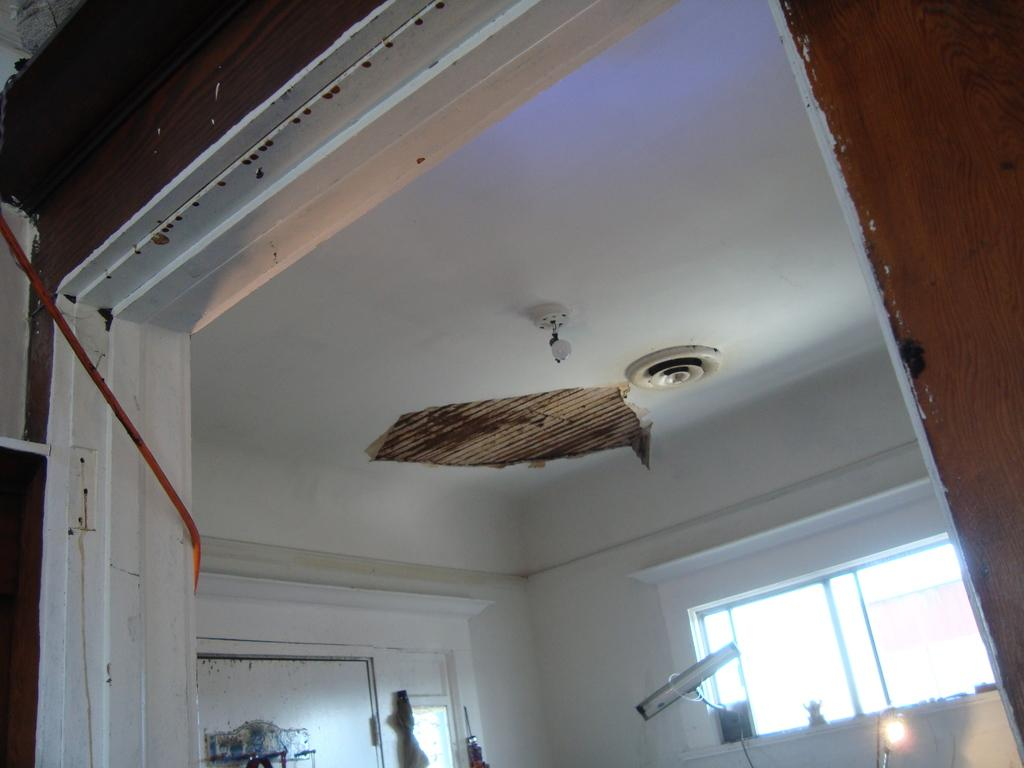Where was the image taken? The image was taken indoors. What architectural features can be seen in the image? There are walls with windows and a door in the image. What is above the room in the image? There is a ceiling in the image. How many dolls are sleeping on the floor in the image? There are no dolls or sleeping figures present in the image. 